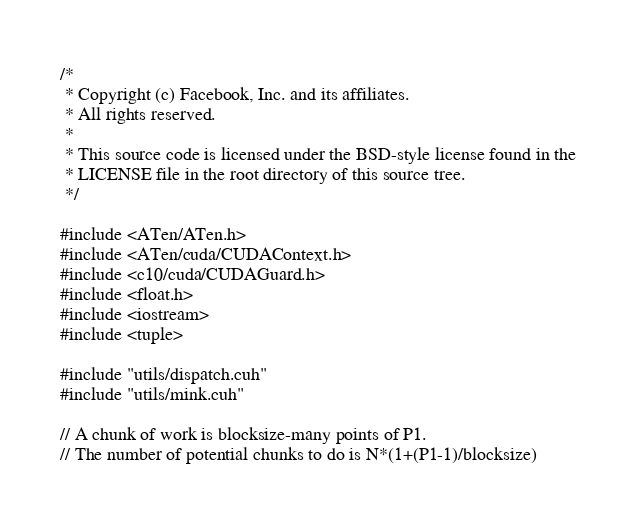Convert code to text. <code><loc_0><loc_0><loc_500><loc_500><_Cuda_>/*
 * Copyright (c) Facebook, Inc. and its affiliates.
 * All rights reserved.
 *
 * This source code is licensed under the BSD-style license found in the
 * LICENSE file in the root directory of this source tree.
 */

#include <ATen/ATen.h>
#include <ATen/cuda/CUDAContext.h>
#include <c10/cuda/CUDAGuard.h>
#include <float.h>
#include <iostream>
#include <tuple>

#include "utils/dispatch.cuh"
#include "utils/mink.cuh"

// A chunk of work is blocksize-many points of P1.
// The number of potential chunks to do is N*(1+(P1-1)/blocksize)</code> 